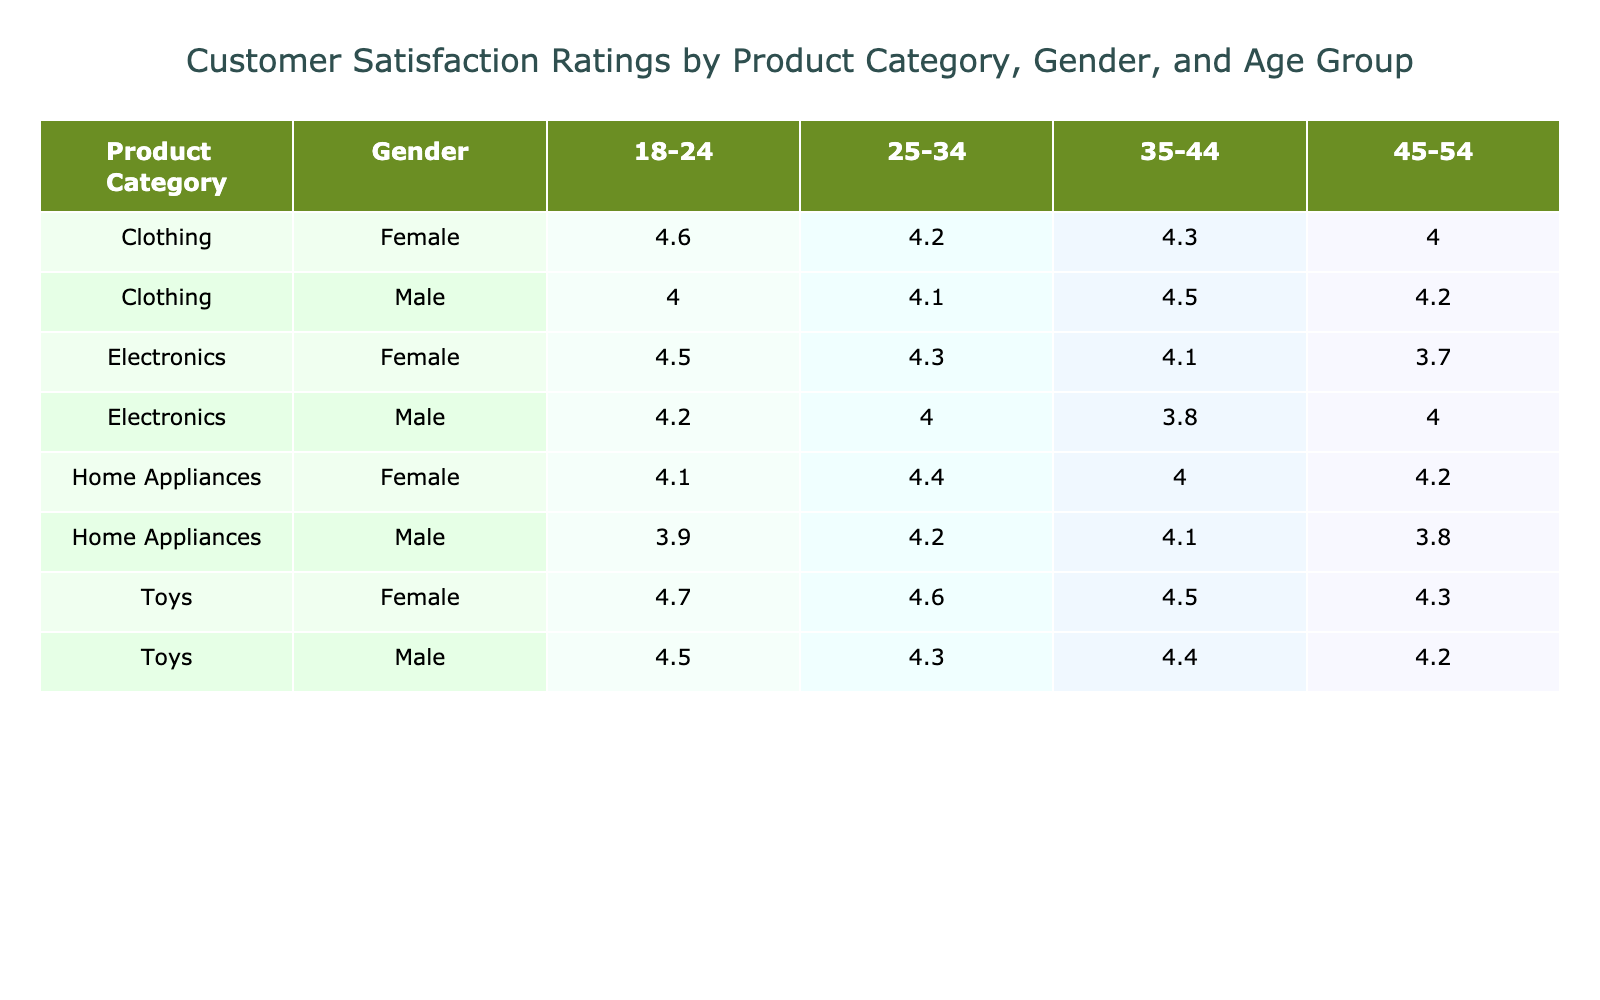What is the customer satisfaction rating for Electronics among females aged 25-34? From the table, we can locate the row corresponding to the product category "Electronics", gender "Female", and age group "25-34". The customer satisfaction rating listed in this row is 4.3.
Answer: 4.3 What is the average customer satisfaction rating for Toys among males? To find this, we locate all rows with the product category "Toys" and the gender "Male". The ratings for males are 4.5, 4.3, 4.4, and 4.2. We calculate the average: (4.5 + 4.3 + 4.4 + 4.2) / 4 = 4.35.
Answer: 4.35 Is the customer satisfaction rating for Home Appliances lower than that for Clothing among females aged 18-24? The rating for "Home Appliances" for females aged 18-24 is 4.1, while the rating for "Clothing" for the same demographic is 4.6. Since 4.1 is less than 4.6, the answer is yes.
Answer: Yes What is the highest customer satisfaction rating among males in the 35-44 age group, and what product category does it belong to? We need to look at all rows for males within the 35-44 age group. The ratings are 4.1 (Home Appliances), 4.5 (Clothing), and 4.4 (Toys). The highest among these is 4.5 for the product category "Clothing".
Answer: 4.5, Clothing Which gender has a higher rating for Home Appliances in the age group 25-34? We compare the ratings in the "Home Appliances" category for each gender in the 25-34 age group. The rating for females is 4.4, while for males, it is 4.2. Since 4.4 is greater than 4.2, females have the higher rating.
Answer: Female What is the customer satisfaction rating for Clothing among males aged 45-54? We check the row for "Clothing", "Male", and age group "45-54". The rating specified in this row is 4.2.
Answer: 4.2 How many product categories have a customer satisfaction rating above 4.4 for males in the 25-34 age group? First, we look for the relevant rows for males aged 25-34 across all product categories. The ratings are: Electronics (4.0), Clothing (4.1), Home Appliances (4.2), Toys (4.3). The only rating above 4.4 is for "Toys" and it is 4.3. Thus, there is 1 product category with a rating above 4.4.
Answer: 1 Is the customer satisfaction rating for Toys higher among females in the 18-24 age group than among males in the same age group? For females aged 18-24, the rating for "Toys" is 4.7, while for males in that group, it is 4.5. Since 4.7 is higher than 4.5, the answer is yes.
Answer: Yes 